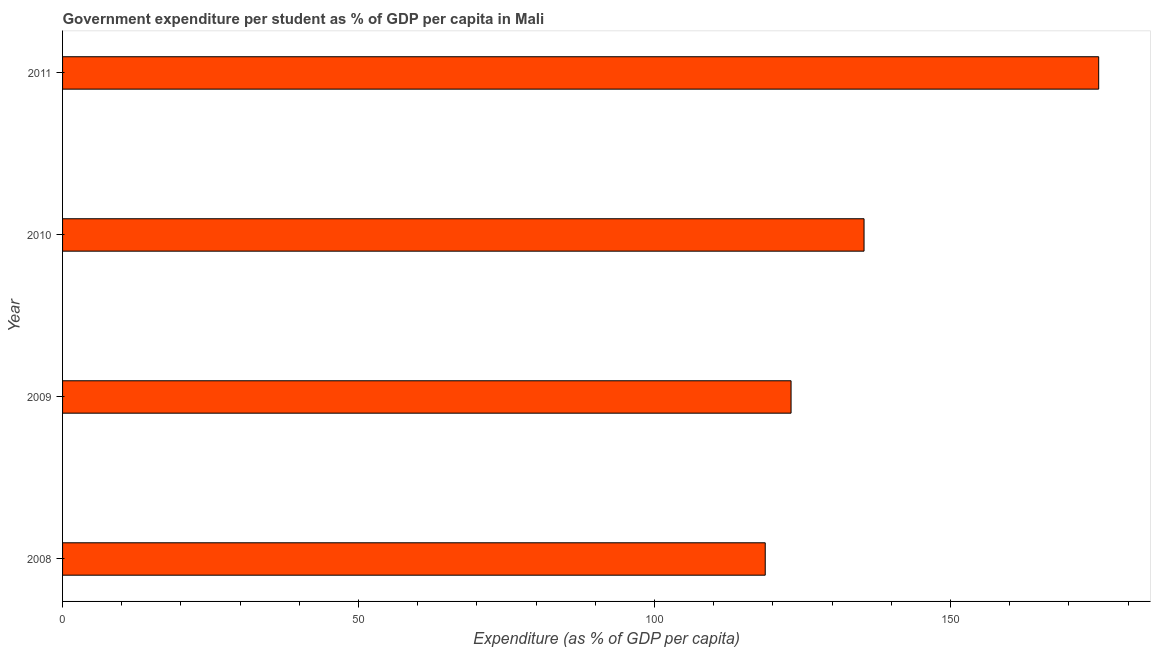Does the graph contain any zero values?
Make the answer very short. No. What is the title of the graph?
Keep it short and to the point. Government expenditure per student as % of GDP per capita in Mali. What is the label or title of the X-axis?
Your response must be concise. Expenditure (as % of GDP per capita). What is the label or title of the Y-axis?
Give a very brief answer. Year. What is the government expenditure per student in 2010?
Your answer should be compact. 135.4. Across all years, what is the maximum government expenditure per student?
Keep it short and to the point. 175.04. Across all years, what is the minimum government expenditure per student?
Your answer should be very brief. 118.71. What is the sum of the government expenditure per student?
Give a very brief answer. 552.23. What is the difference between the government expenditure per student in 2008 and 2011?
Ensure brevity in your answer.  -56.33. What is the average government expenditure per student per year?
Offer a very short reply. 138.06. What is the median government expenditure per student?
Provide a succinct answer. 129.24. What is the ratio of the government expenditure per student in 2008 to that in 2011?
Make the answer very short. 0.68. Is the government expenditure per student in 2009 less than that in 2011?
Make the answer very short. Yes. Is the difference between the government expenditure per student in 2009 and 2011 greater than the difference between any two years?
Keep it short and to the point. No. What is the difference between the highest and the second highest government expenditure per student?
Make the answer very short. 39.64. Is the sum of the government expenditure per student in 2008 and 2009 greater than the maximum government expenditure per student across all years?
Your answer should be very brief. Yes. What is the difference between the highest and the lowest government expenditure per student?
Provide a short and direct response. 56.33. In how many years, is the government expenditure per student greater than the average government expenditure per student taken over all years?
Your answer should be compact. 1. How many bars are there?
Give a very brief answer. 4. Are all the bars in the graph horizontal?
Your response must be concise. Yes. Are the values on the major ticks of X-axis written in scientific E-notation?
Provide a succinct answer. No. What is the Expenditure (as % of GDP per capita) in 2008?
Offer a terse response. 118.71. What is the Expenditure (as % of GDP per capita) in 2009?
Offer a very short reply. 123.07. What is the Expenditure (as % of GDP per capita) of 2010?
Offer a terse response. 135.4. What is the Expenditure (as % of GDP per capita) in 2011?
Provide a short and direct response. 175.04. What is the difference between the Expenditure (as % of GDP per capita) in 2008 and 2009?
Your answer should be compact. -4.36. What is the difference between the Expenditure (as % of GDP per capita) in 2008 and 2010?
Offer a terse response. -16.69. What is the difference between the Expenditure (as % of GDP per capita) in 2008 and 2011?
Offer a very short reply. -56.33. What is the difference between the Expenditure (as % of GDP per capita) in 2009 and 2010?
Ensure brevity in your answer.  -12.33. What is the difference between the Expenditure (as % of GDP per capita) in 2009 and 2011?
Offer a terse response. -51.97. What is the difference between the Expenditure (as % of GDP per capita) in 2010 and 2011?
Provide a succinct answer. -39.64. What is the ratio of the Expenditure (as % of GDP per capita) in 2008 to that in 2009?
Offer a very short reply. 0.96. What is the ratio of the Expenditure (as % of GDP per capita) in 2008 to that in 2010?
Offer a terse response. 0.88. What is the ratio of the Expenditure (as % of GDP per capita) in 2008 to that in 2011?
Keep it short and to the point. 0.68. What is the ratio of the Expenditure (as % of GDP per capita) in 2009 to that in 2010?
Ensure brevity in your answer.  0.91. What is the ratio of the Expenditure (as % of GDP per capita) in 2009 to that in 2011?
Your answer should be compact. 0.7. What is the ratio of the Expenditure (as % of GDP per capita) in 2010 to that in 2011?
Provide a short and direct response. 0.77. 